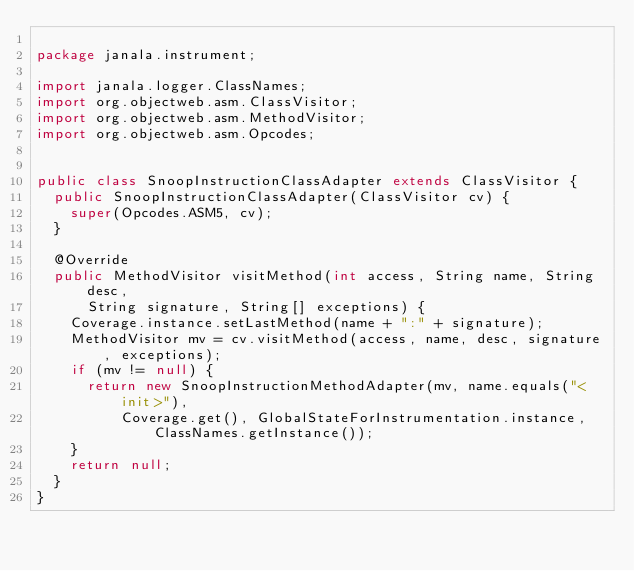<code> <loc_0><loc_0><loc_500><loc_500><_Java_>
package janala.instrument;

import janala.logger.ClassNames;
import org.objectweb.asm.ClassVisitor;
import org.objectweb.asm.MethodVisitor;
import org.objectweb.asm.Opcodes;


public class SnoopInstructionClassAdapter extends ClassVisitor {
  public SnoopInstructionClassAdapter(ClassVisitor cv) {
    super(Opcodes.ASM5, cv);
  }

  @Override
  public MethodVisitor visitMethod(int access, String name, String desc, 
      String signature, String[] exceptions) {
    Coverage.instance.setLastMethod(name + ":" + signature);
    MethodVisitor mv = cv.visitMethod(access, name, desc, signature, exceptions);
    if (mv != null) {
      return new SnoopInstructionMethodAdapter(mv, name.equals("<init>"), 
          Coverage.get(), GlobalStateForInstrumentation.instance, ClassNames.getInstance());
    }
    return null;
  }
}
</code> 